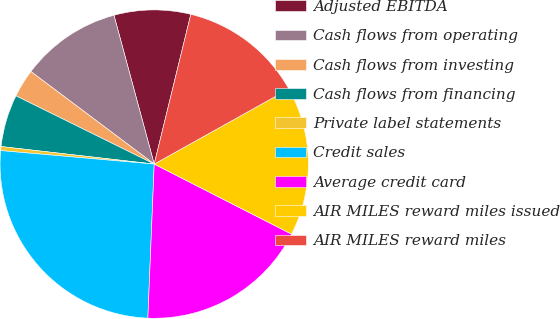Convert chart. <chart><loc_0><loc_0><loc_500><loc_500><pie_chart><fcel>Adjusted EBITDA<fcel>Cash flows from operating<fcel>Cash flows from investing<fcel>Cash flows from financing<fcel>Private label statements<fcel>Credit sales<fcel>Average credit card<fcel>AIR MILES reward miles issued<fcel>AIR MILES reward miles<nl><fcel>8.02%<fcel>10.55%<fcel>2.95%<fcel>5.48%<fcel>0.42%<fcel>25.74%<fcel>18.15%<fcel>15.61%<fcel>13.08%<nl></chart> 